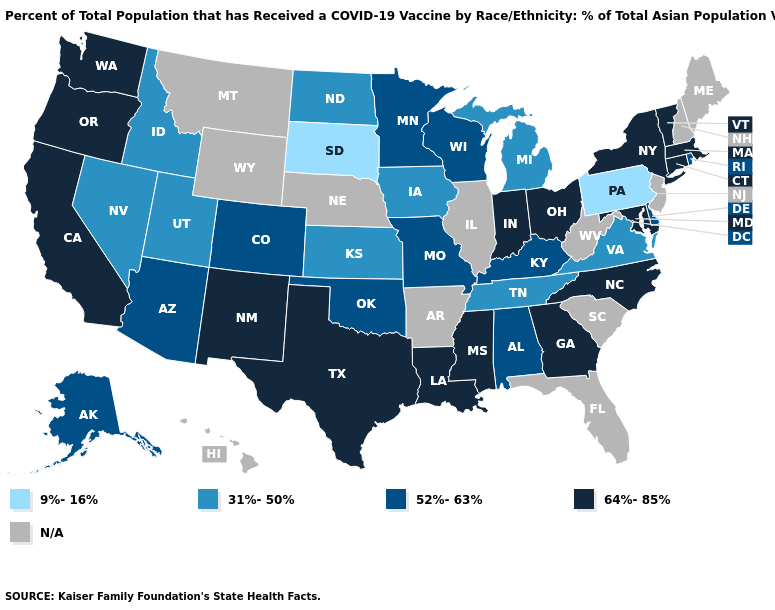Name the states that have a value in the range 31%-50%?
Quick response, please. Idaho, Iowa, Kansas, Michigan, Nevada, North Dakota, Tennessee, Utah, Virginia. What is the value of Michigan?
Keep it brief. 31%-50%. What is the value of Connecticut?
Answer briefly. 64%-85%. Among the states that border Missouri , does Kentucky have the lowest value?
Short answer required. No. Is the legend a continuous bar?
Write a very short answer. No. What is the value of West Virginia?
Quick response, please. N/A. What is the value of North Carolina?
Quick response, please. 64%-85%. What is the lowest value in the MidWest?
Quick response, please. 9%-16%. Which states have the lowest value in the USA?
Short answer required. Pennsylvania, South Dakota. What is the value of New Hampshire?
Give a very brief answer. N/A. Name the states that have a value in the range 31%-50%?
Short answer required. Idaho, Iowa, Kansas, Michigan, Nevada, North Dakota, Tennessee, Utah, Virginia. What is the value of Nebraska?
Write a very short answer. N/A. Does Arizona have the highest value in the USA?
Be succinct. No. 